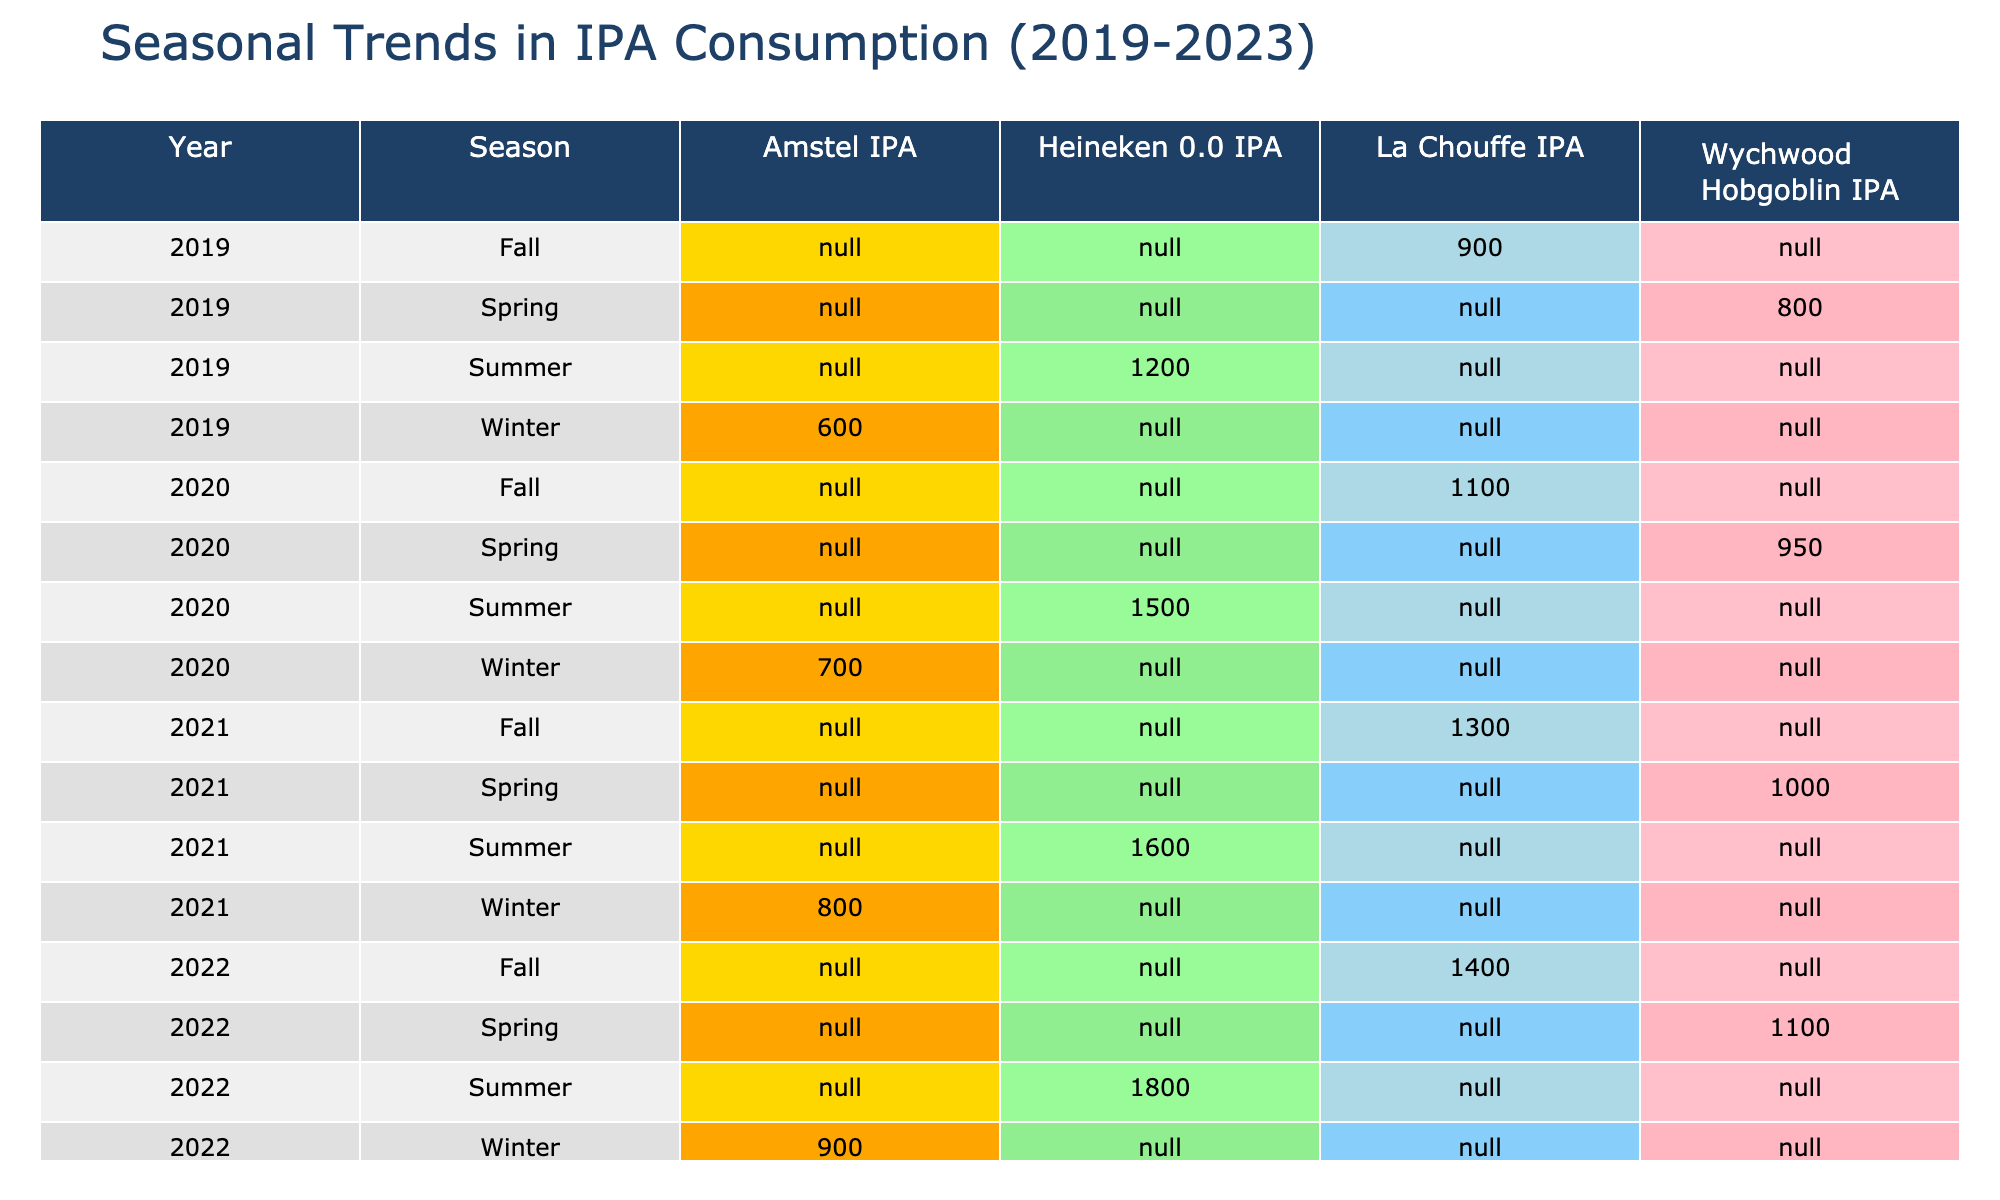What was the highest consumption volume of Heineken 0.0 IPA during the five years? In the table, I look at the row where "Heineken 0.0 IPA" is listed and find the highest value across all seasons and years. The values are 1200, 1500, 1600, 1800, and 1900 liters for the respective years. The highest value is 1900 liters in the summer of 2023.
Answer: 1900 liters How much did the consumption of La Chouffe IPA increase from 2019 to 2023? I first extract the consumption volumes for "La Chouffe IPA" for the years 2019 (900 liters) and 2023 (1500 liters). To find the increase, I subtract 900 from 1500, which gives me 600 liters increase in consumption over the four years.
Answer: 600 liters Was the consumption of Amstel IPA in spring ever higher than 1000 liters during these years? I check the entries for "Amstel IPA" in the spring seasons across the years. The values recorded are 800 in 2019, 700 in 2020, 1000 in 2021, 900 in 2022, and 1200 in 2023. Since 1200 liters in 2023 is the only instance when it was above 1000 liters, the answer to the question is yes.
Answer: Yes What is the total consumption of Wychwood Hobgoblin IPA over all five years? I list out each season's consumption for "Wychwood Hobgoblin IPA": 800 (2019 Spring) + 950 (2020 Spring) + 1000 (2021 Spring) + 1100 (2022 Spring) + 1200 (2023 Spring) = 4050 liters. Therefore, I sum these amounts to find the total consumption over the years.
Answer: 4050 liters Did La Chouffe IPA have higher consumption in the summer or fall of 2022? I find both summer and fall consumptions for La Chouffe IPA in 2022; the values are 1400 liters (fall) and 1500 liters (summer). Since 1500 liters in summer is greater than 1400 liters in fall, it shows that summer had higher consumption in that year.
Answer: Summer had higher consumption 